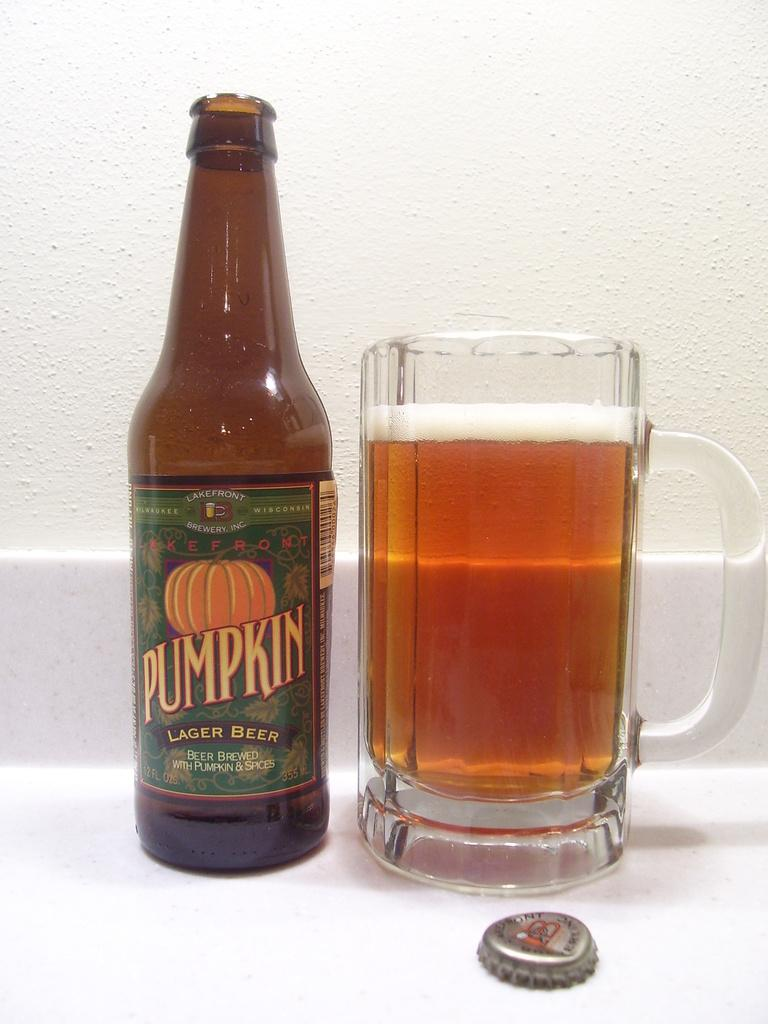<image>
Write a terse but informative summary of the picture. A tall glass of frothy beer is standing next to an open bottle of Lakefront Pumpkin beer. 